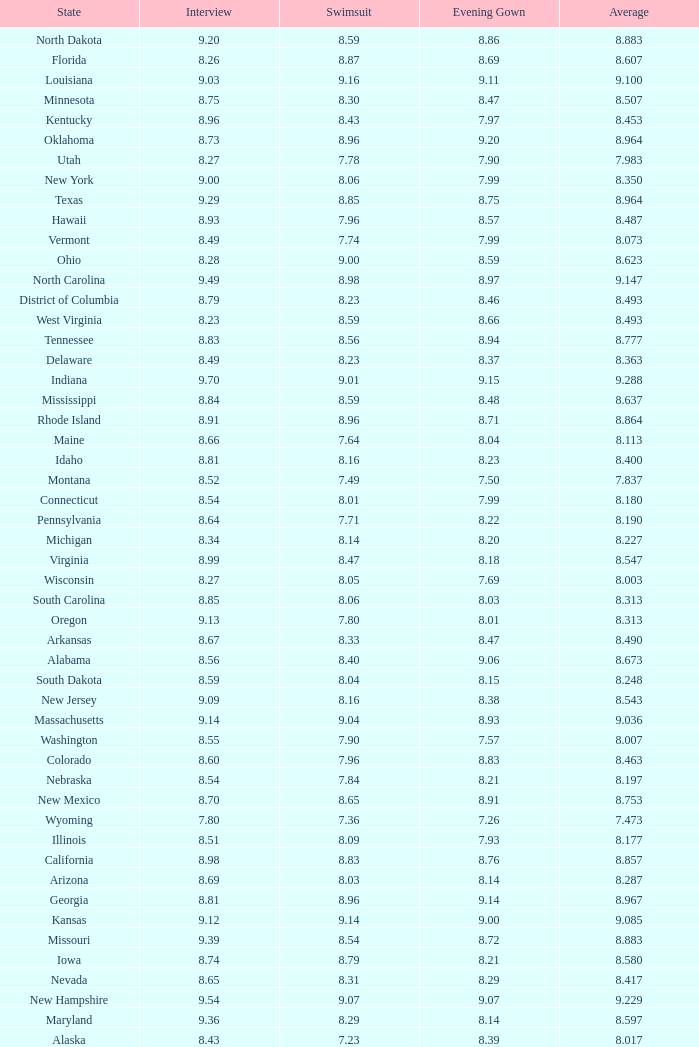Name the total number of swimsuits for evening gowns less than 8.21 and average of 8.453 with interview less than 9.09 1.0. 